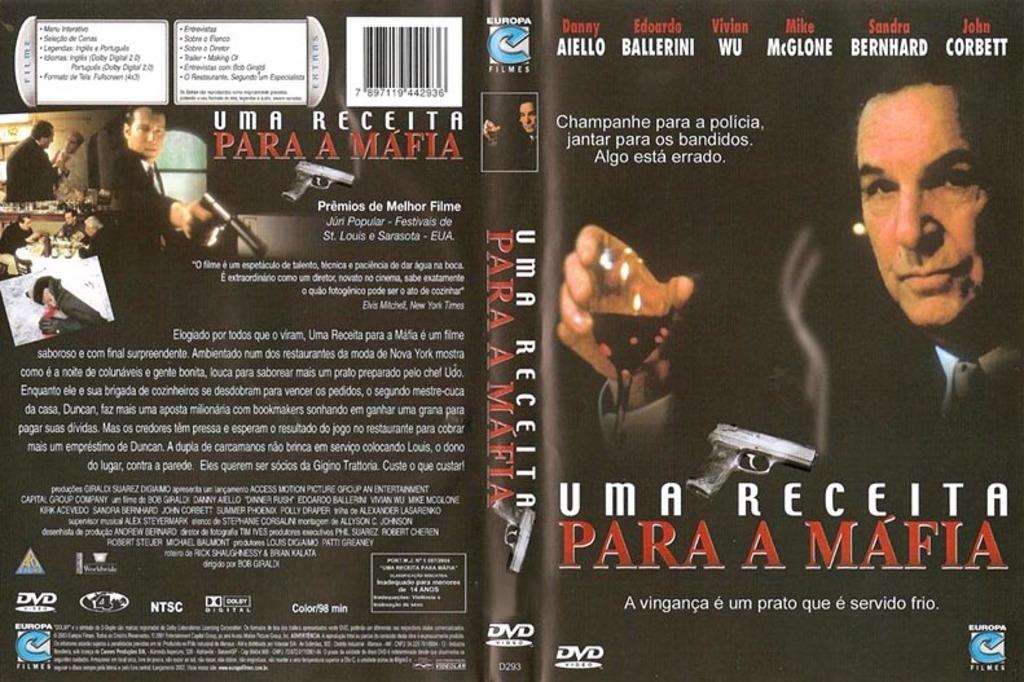What is featured in the image? There is a poster in the image. What can be seen on the poster? The poster contains a group of people. Is there any text on the poster? Yes, there is text written on the poster. How many pets are sitting on the shelf in the image? There is no shelf or pets present in the image; it features a poster with a group of people and text. 